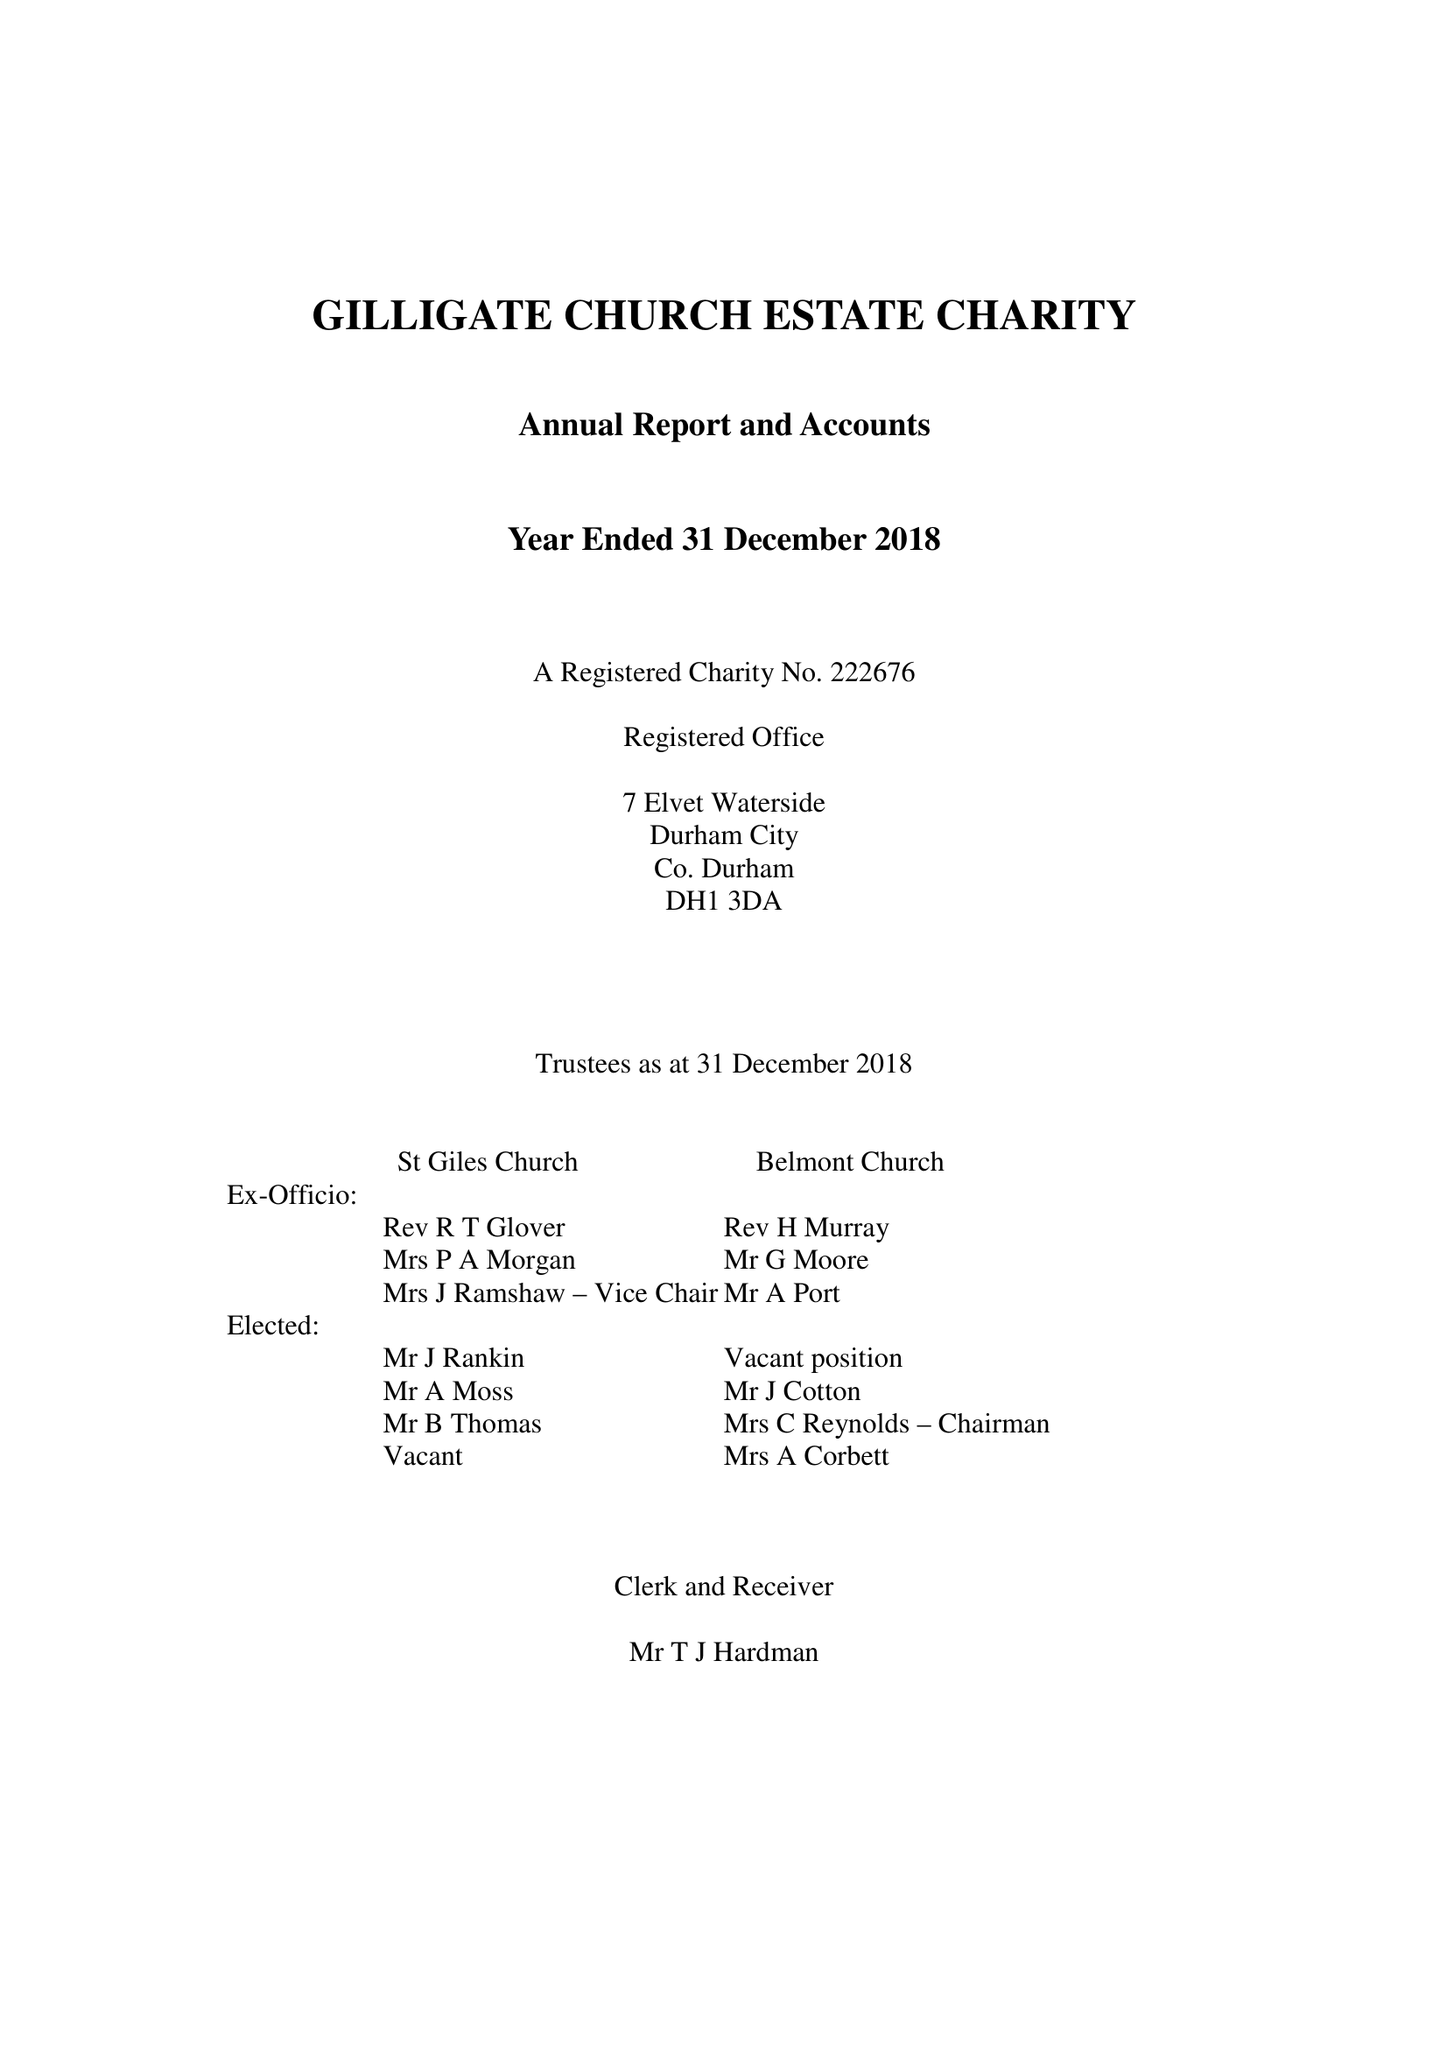What is the value for the address__post_town?
Answer the question using a single word or phrase. DURHAM 